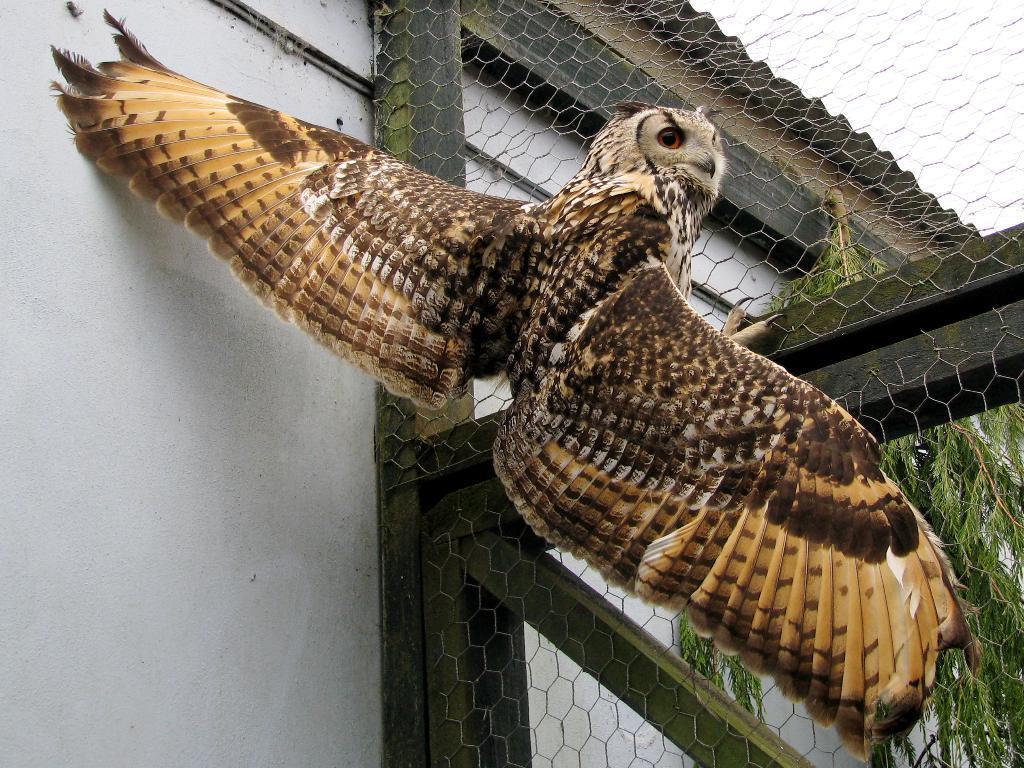Could you give a brief overview of what you see in this image? In this picture we can see brown owl is sitting on the net frame. Behind we can see the white wall and tree in the background. 